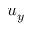Convert formula to latex. <formula><loc_0><loc_0><loc_500><loc_500>u _ { y }</formula> 